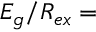<formula> <loc_0><loc_0><loc_500><loc_500>E _ { g } / R _ { e x } =</formula> 